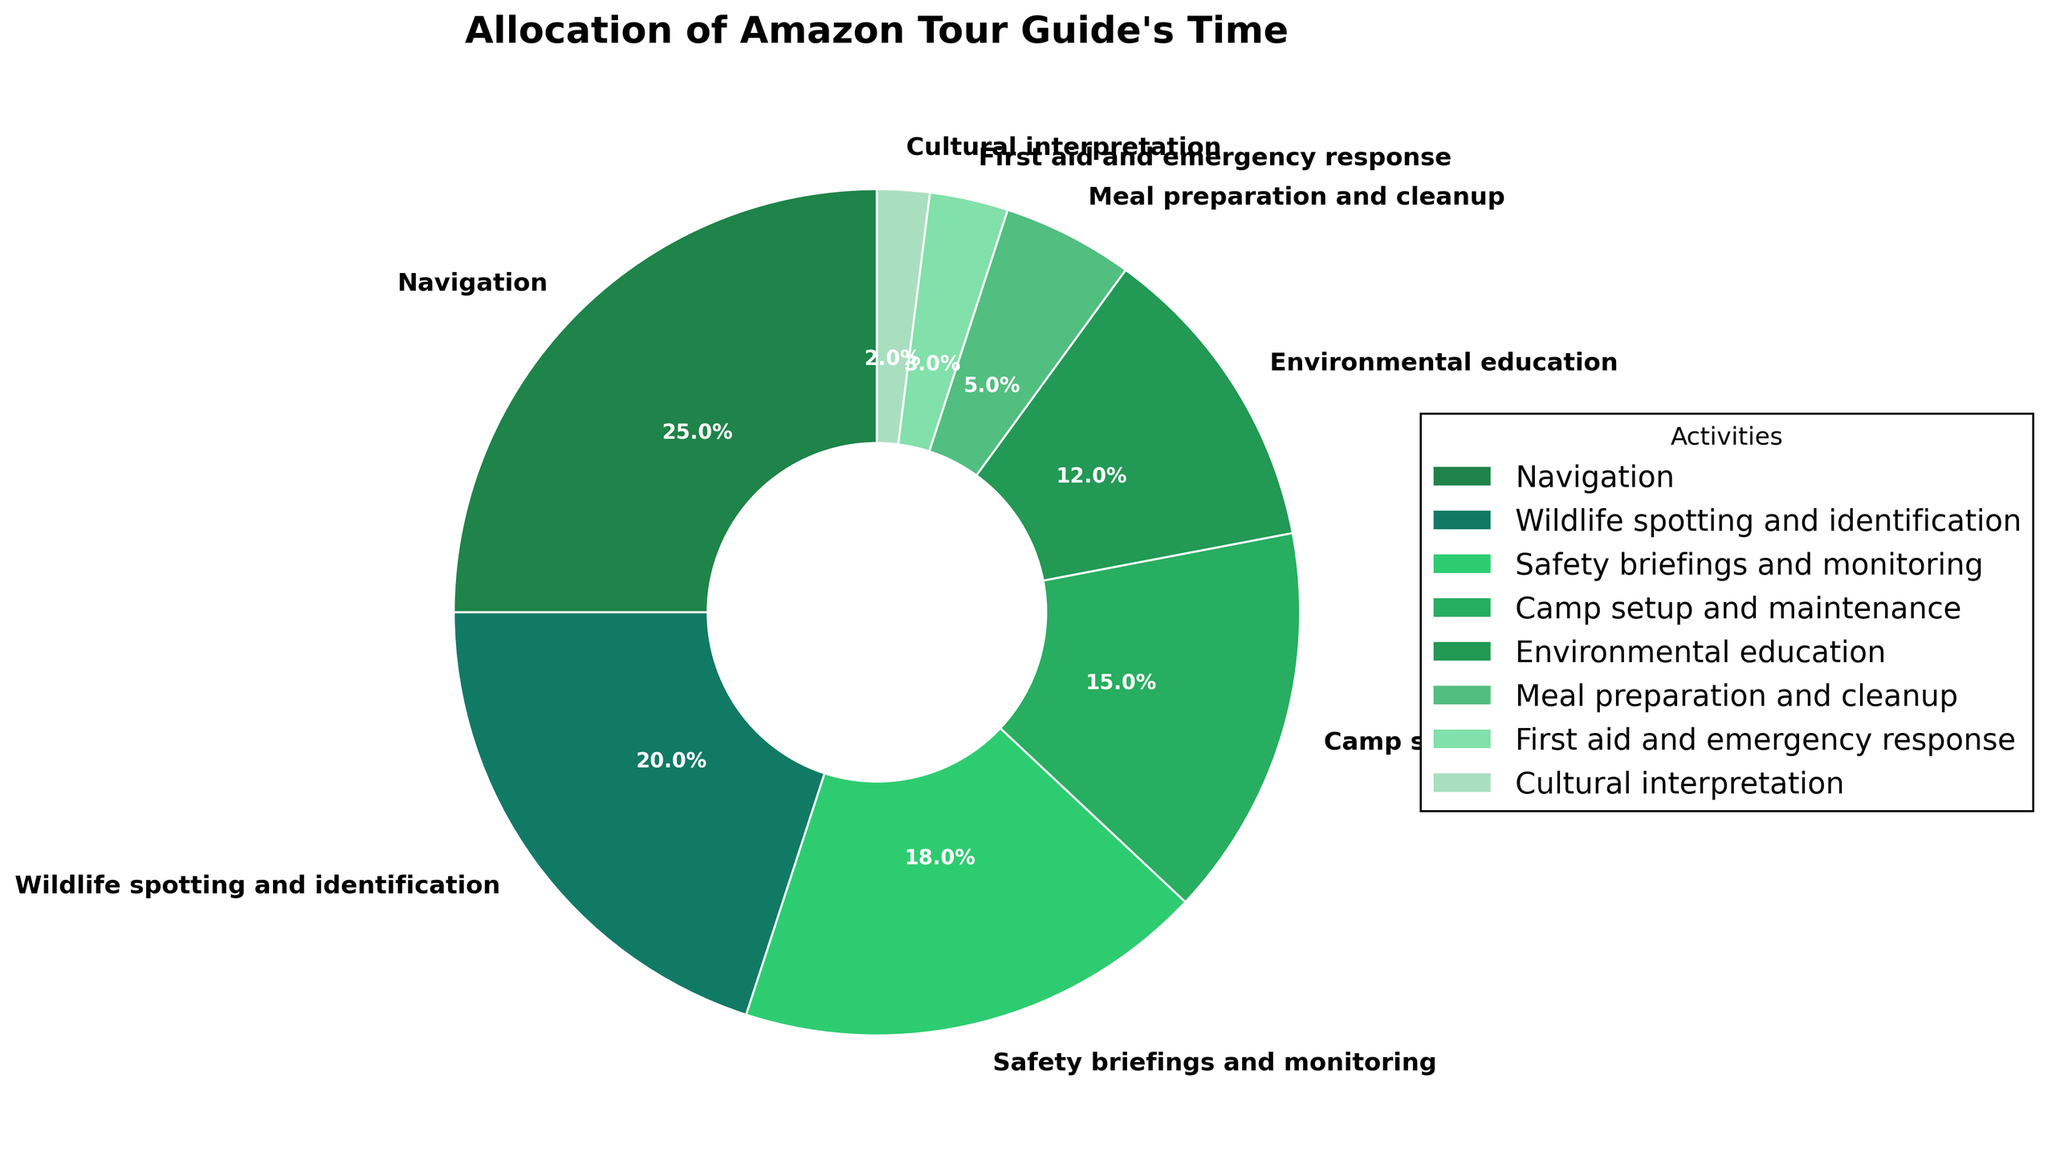What's the combined percentage of time spent on navigation and wildlife spotting and identification? To find the combined percentage, add the percentages of time spent on navigation (25%) and wildlife spotting and identification (20%): 25% + 20% = 45%
Answer: 45% Which two activities together account for the largest proportion of the tour guide's time? To determine the largest combined proportion, identify the top two percentages. Navigation (25%) and wildlife spotting and identification (20%) are the largest: 25% + 20% = 45%
Answer: Navigation and Wildlife spotting and identification What's the difference in percentage between the time spent on environmental education and camp setup and maintenance? Subtract the percentage for environmental education (12%) from camp setup and maintenance (15%): 15% - 12% = 3%
Answer: 3% Which activity has the smallest allocation of time, and how much is it? Identify the activity with the smallest percentage. Cultural interpretation has 2%, which is the smallest allocation
Answer: Cultural interpretation, 2% What's the total percentage of time spent on safety briefings and monitoring, environmental education, and cultural interpretation? Sum the percentages for these activities: Safety briefings and monitoring (18%), environmental education (12%), and cultural interpretation (2%). 18% + 12% + 2% = 32%
Answer: 32% Which activity has a larger allocation of time: camp setup and maintenance or meal preparation and cleanup? Compare the percentages. Camp setup and maintenance has 15%, while meal preparation and cleanup has 5%. 15% is larger than 5%
Answer: Camp setup and maintenance What proportion of the time is spent on tasks related to safety (safety briefings and monitoring, first aid and emergency response)? Sum the percentages for safety briefings and monitoring (18%) and first aid and emergency response (3%): 18% + 3% = 21%
Answer: 21% If the time spent on navigation was reduced by 5% and this time was equally redistributed among meal preparation and cleanup and first aid and emergency response, what would be their new percentages? Reduce navigation by 5%: 25% - 5% = 20%. Redistribute 5% equally: 5%/2 = 2.5%. Add 2.5% to meal preparation and cleanup (5% + 2.5% = 7.5%) and first aid and emergency response (3% + 2.5% = 5.5%)
Answer: Meal preparation and cleanup: 7.5%, First aid and emergency response: 5.5% Which activity is represented by a green color in the pie chart? The activities are color-coded with shades of green. From the specific shade hierarchy, Navigation has the darkest green, followed by wildlife spotting and identification
Answer: Navigation How many activities have a percentage higher than 10%? Count the activities with percentages greater than 10%: Navigation (25%), Wildlife spotting and identification (20%), Safety briefings and monitoring (18%), Camp setup and maintenance (15%), Environmental education (12%). There are 5 such activities
Answer: 5 